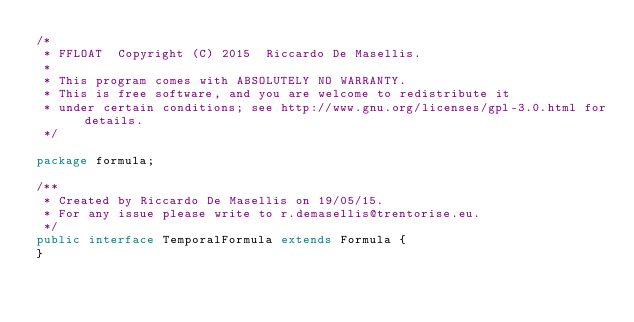<code> <loc_0><loc_0><loc_500><loc_500><_Java_>/*
 * FFLOAT  Copyright (C) 2015  Riccardo De Masellis.
 *
 * This program comes with ABSOLUTELY NO WARRANTY.
 * This is free software, and you are welcome to redistribute it
 * under certain conditions; see http://www.gnu.org/licenses/gpl-3.0.html for details.
 */

package formula;

/**
 * Created by Riccardo De Masellis on 19/05/15.
 * For any issue please write to r.demasellis@trentorise.eu.
 */
public interface TemporalFormula extends Formula {
}
</code> 